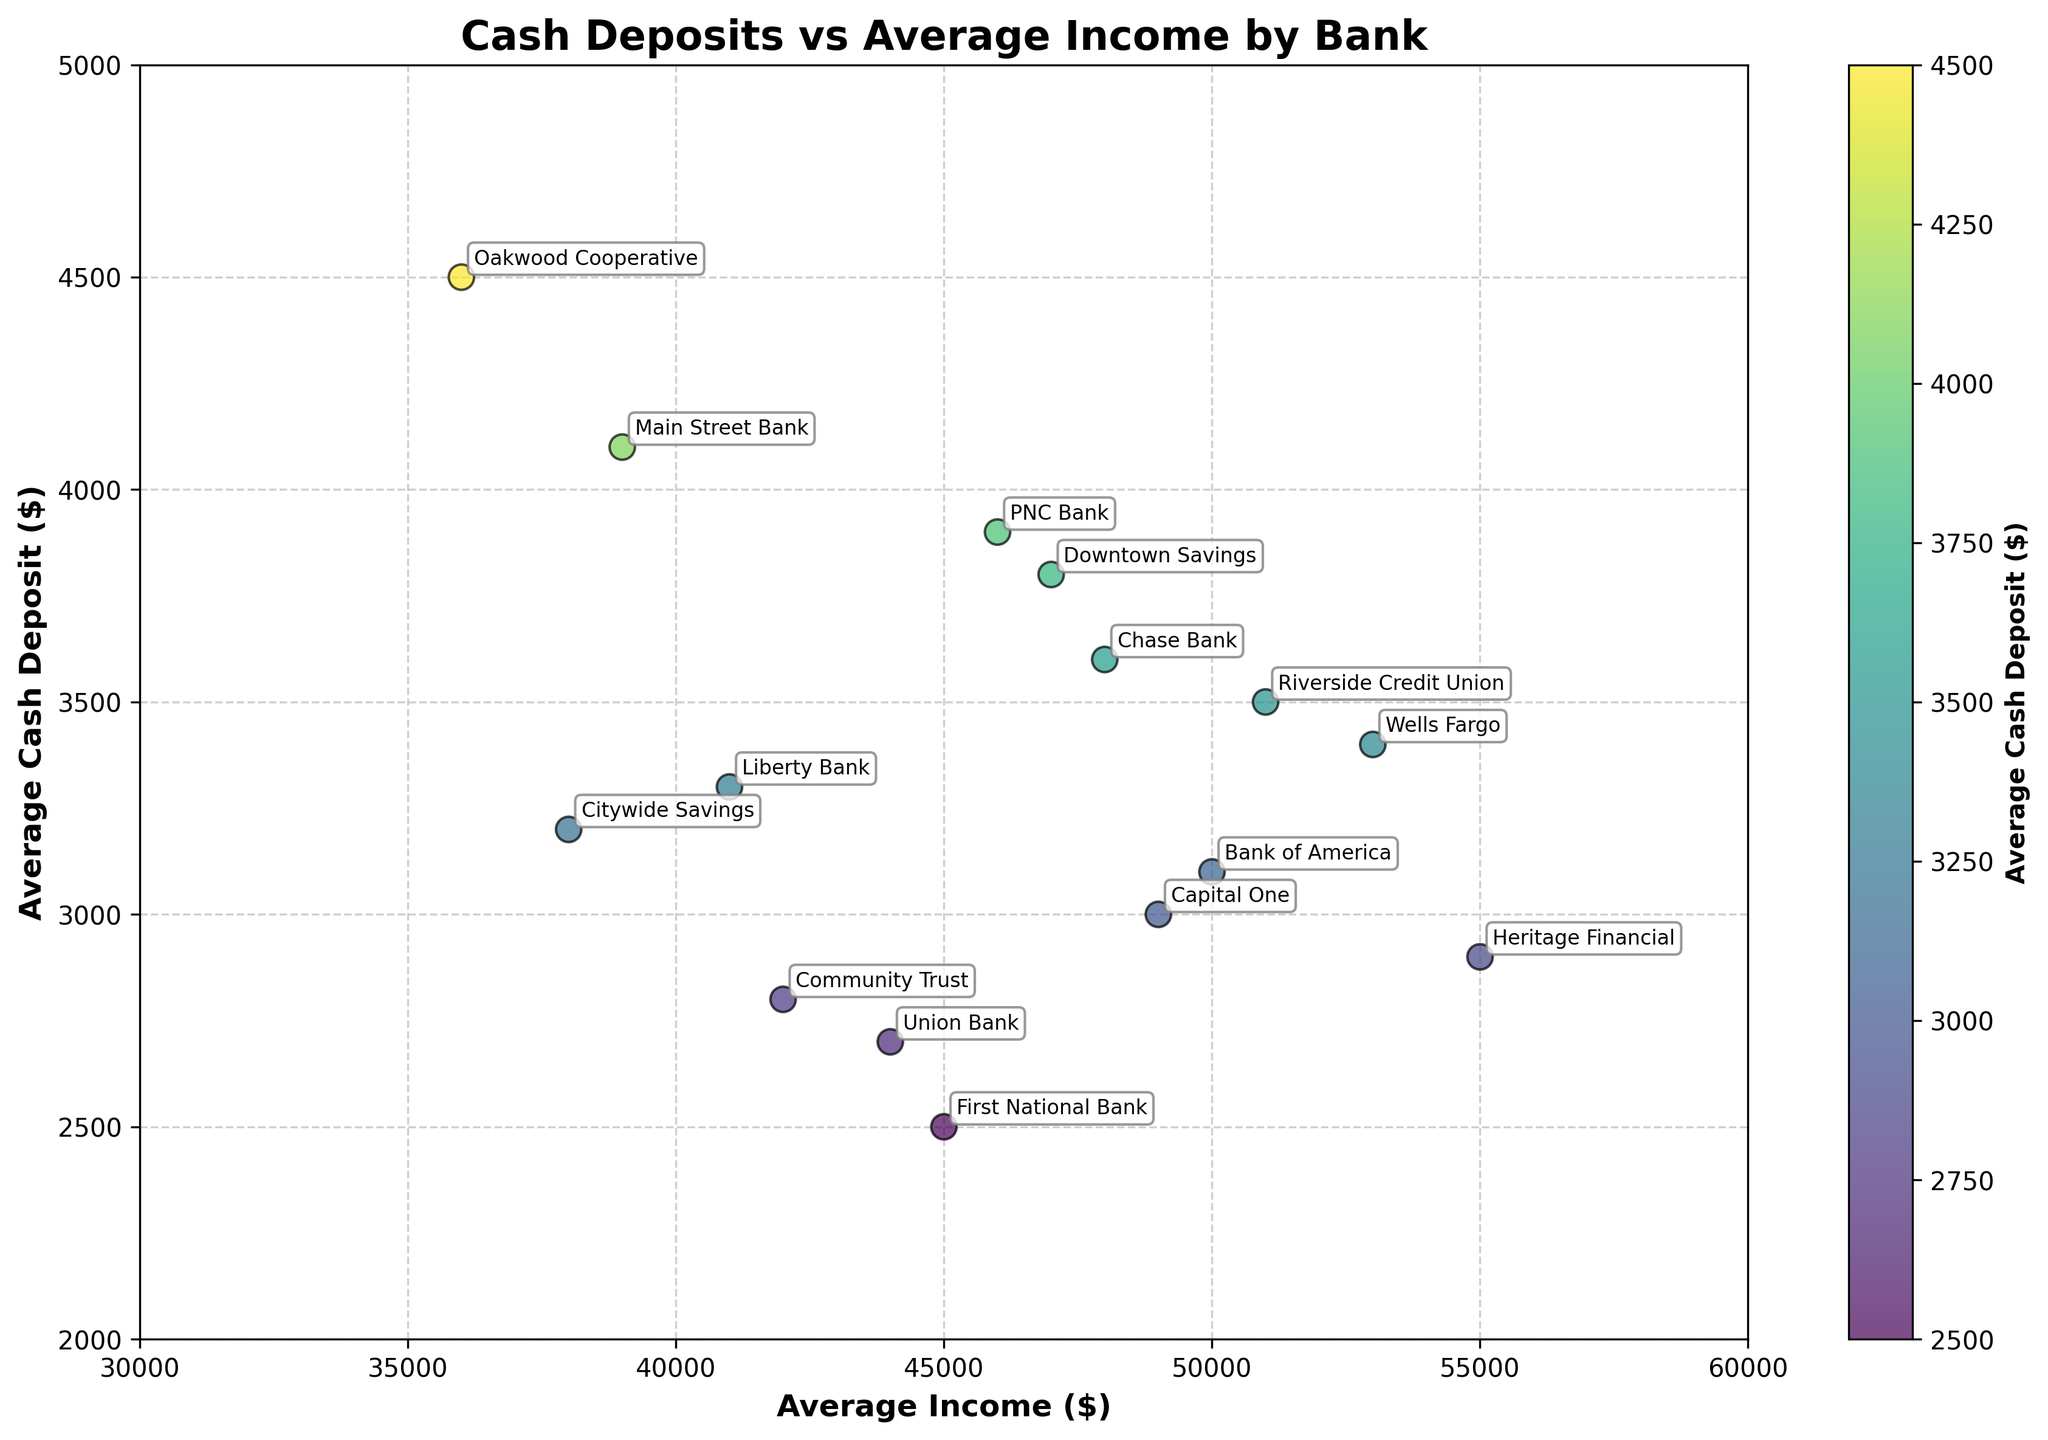What's the title of the figure? The title of the figure is displayed at the top center of the scatter plot. It is a description of what the plot is about.
Answer: Cash Deposits vs Average Income by Bank Which bank has the highest average income? To determine the bank with the highest average income, look for the data point that has the maximum value on the X-axis (Average Income).
Answer: Heritage Financial What is the average cash deposit for Main Street Bank? Find the data point labeled as "Main Street Bank" and then read off the corresponding Y-axis value, which represents the average cash deposit for that bank.
Answer: 4100 Which bank has the largest average cash deposit and what is its value? Find the data point that has the maximum value on the Y-axis (Average Cash Deposit) and note the bank associated with it.
Answer: Oakwood Cooperative, 4500 Compare the average cash deposits between Citywide Savings and Chase Bank. Identify the data points for both "Citywide Savings" and "Chase Bank," and then compare their Y-axis values.
Answer: Citywide Savings: 3200, Chase Bank: 3600 How many banks have an average cash deposit above 3000? Count the data points that are positioned above the Y-axis value of 3000.
Answer: 10 What is the color of the data points and what does it represent? The color of the data points is determined by a color spectrum that represents the average cash deposit values, where the color changes from lower to higher average cash deposits.
Answer: Shades of viridis, representing average cash deposits Is there a general trend between average income and average cash deposit? Observe the overall distribution of the data points in terms of their X-axis (Average Income) and Y-axis (Average Cash Deposit) values to identify any upward or downward trends.
Answer: Higher average incomes tend to have varied average cash deposits, no clear linear trend Which bank has the smallest average cash deposit and what is its value? Find the data point that has the minimum value on the Y-axis (Average Cash Deposit) and note the bank associated with it.
Answer: First National Bank, 2500 What is the range of average income values in the figure? To determine the range, find the minimum and maximum values on the X-axis (Average Income) and subtract the minimum value from the maximum value.
Answer: 19000 (55000 - 36000) 